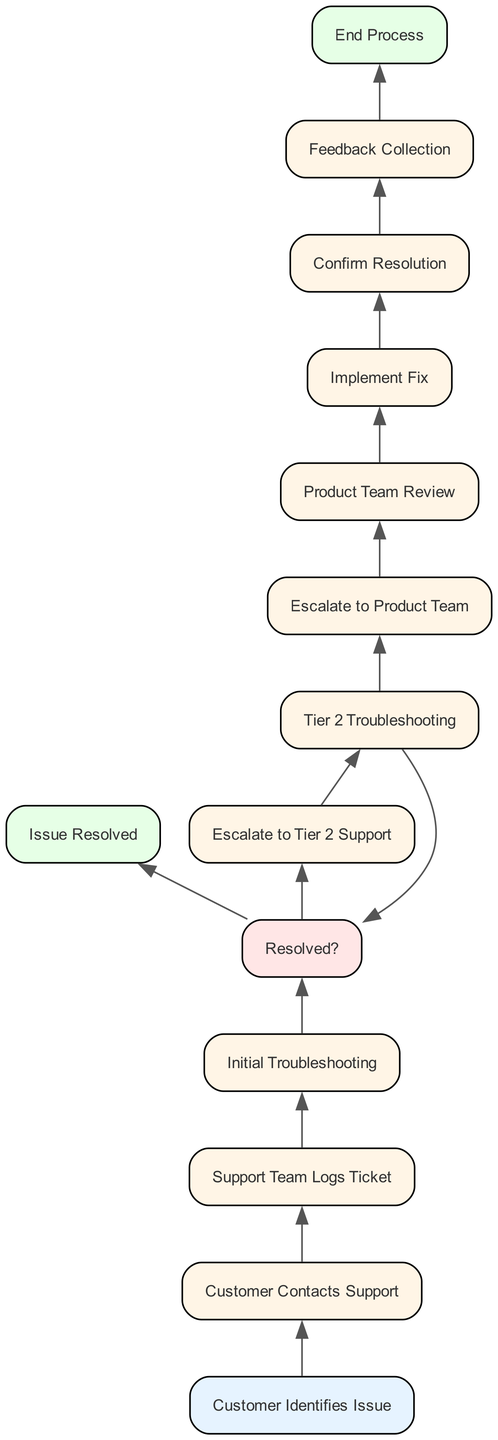What is the first step in the escalation procedure? The first step is when the customer identifies an issue with the product or service, as indicated by the starting node in the flow.
Answer: Customer Identifies Issue How many decision points are in the diagram? There is one decision point in the flowchart, which is represented by the "Resolved?" node.
Answer: 1 What happens if the issue is not resolved during initial troubleshooting? If the issue is not resolved, the process leads to the escalation to Tier 2 support, as shown by the arrow from the "Resolved?" decision node to the "Escalate to Tier 2 Support" process node.
Answer: Escalate to Tier 2 Support Which team is responsible for implementing the fix? The support team is responsible for implementing the fix after it has been developed by the product team. This responsibility follows the "Product Team Review" node, as indicated in the flow.
Answer: Support Team What is the last step in the escalation procedure? The last step in the escalation procedure is when the process ends, signified by the "End Process" node, which shows the completion of the escalation and ticket closure.
Answer: End Process In which stage is customer feedback collected? Customer feedback is collected after the support agent confirms that the issue is resolved, specifically at the "Feedback Collection" stage following the "Confirm Resolution" process.
Answer: Feedback Collection What action is taken if Tier 2 troubleshooting does not resolve the issue? If Tier 2 troubleshooting does not resolve the issue, the next action is to escalate the ticket to the product team for further review and solution development. This is represented by an arrow leading to the "Escalate to Product Team" node.
Answer: Escalate to Product Team What is the relationship between "Initial Troubleshooting" and "Resolved?" The "Initial Troubleshooting" step directly leads to the "Resolved?" decision point, where it checks if the issue was resolved after the troubleshooting effort.
Answer: Directly leads to How many total nodes are in this flowchart? There are fourteen nodes in the flowchart, including the start and end nodes, as counted from the provided elements.
Answer: 14 What process follows after the "Product Team Review"? After the "Product Team Review," the process that follows is the "Implement Fix," where the resolution identified by the product team is executed.
Answer: Implement Fix 